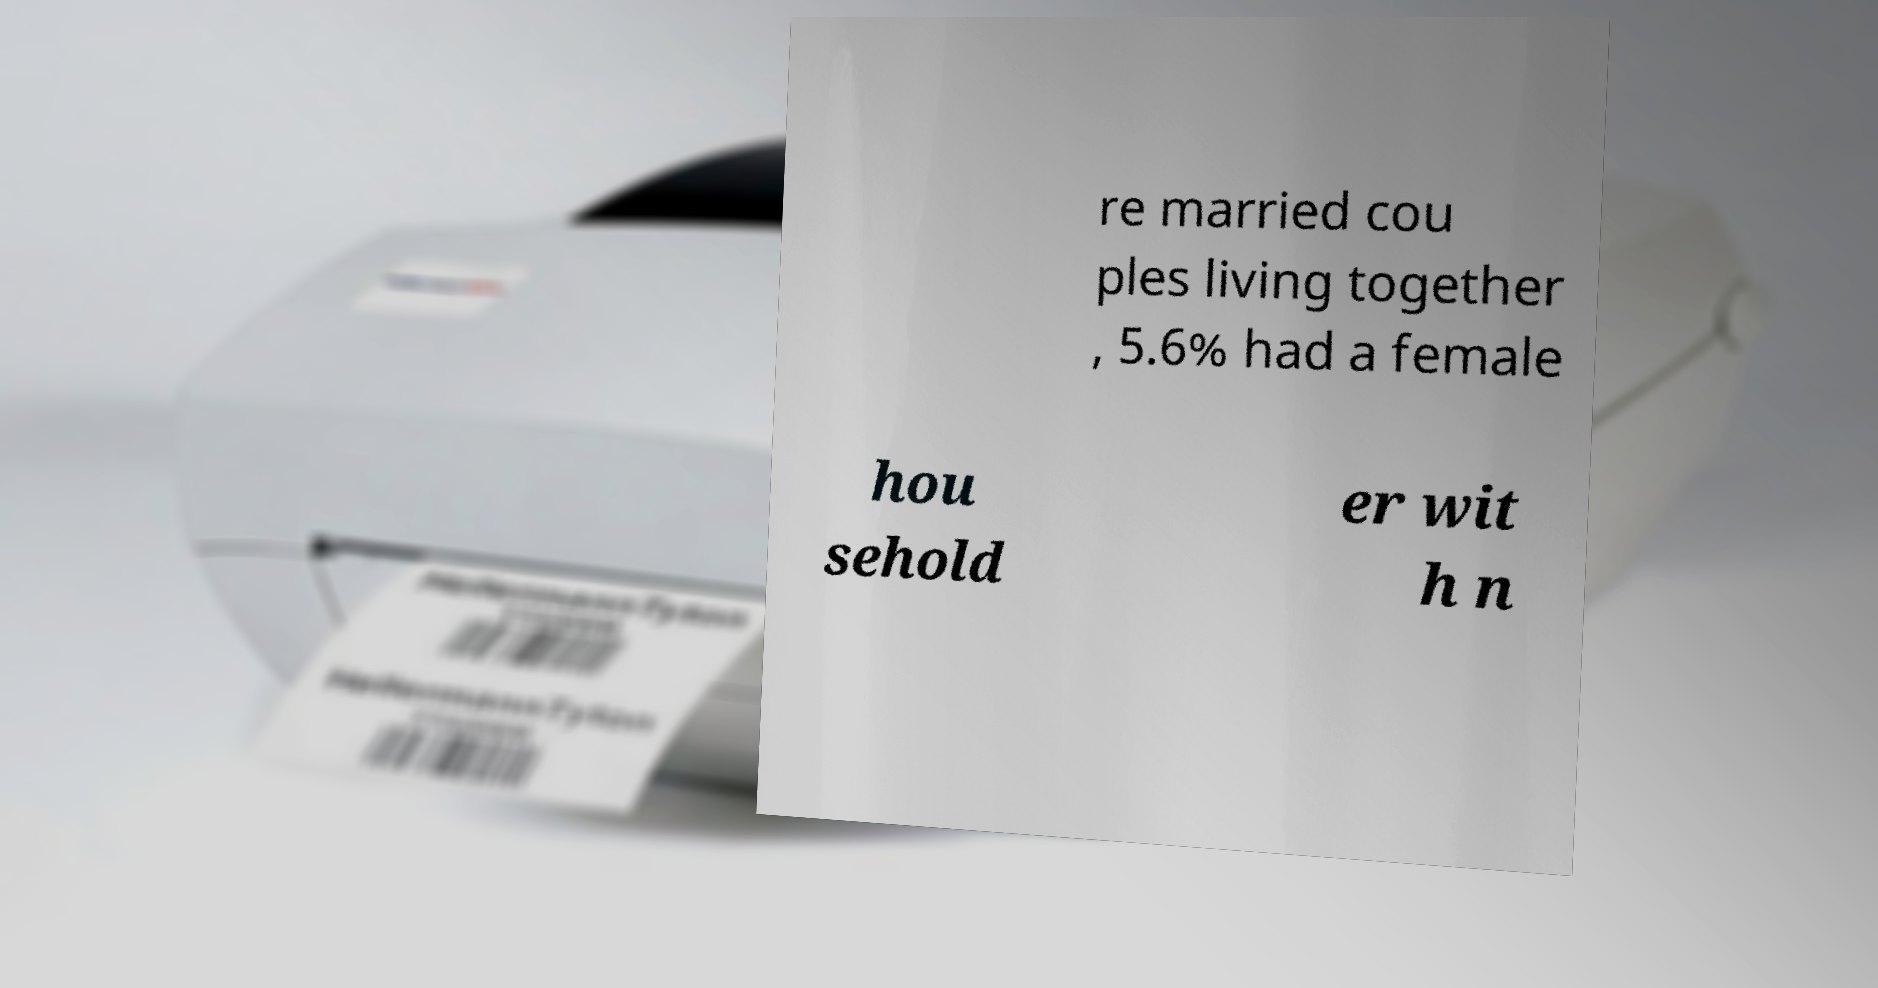Please identify and transcribe the text found in this image. re married cou ples living together , 5.6% had a female hou sehold er wit h n 